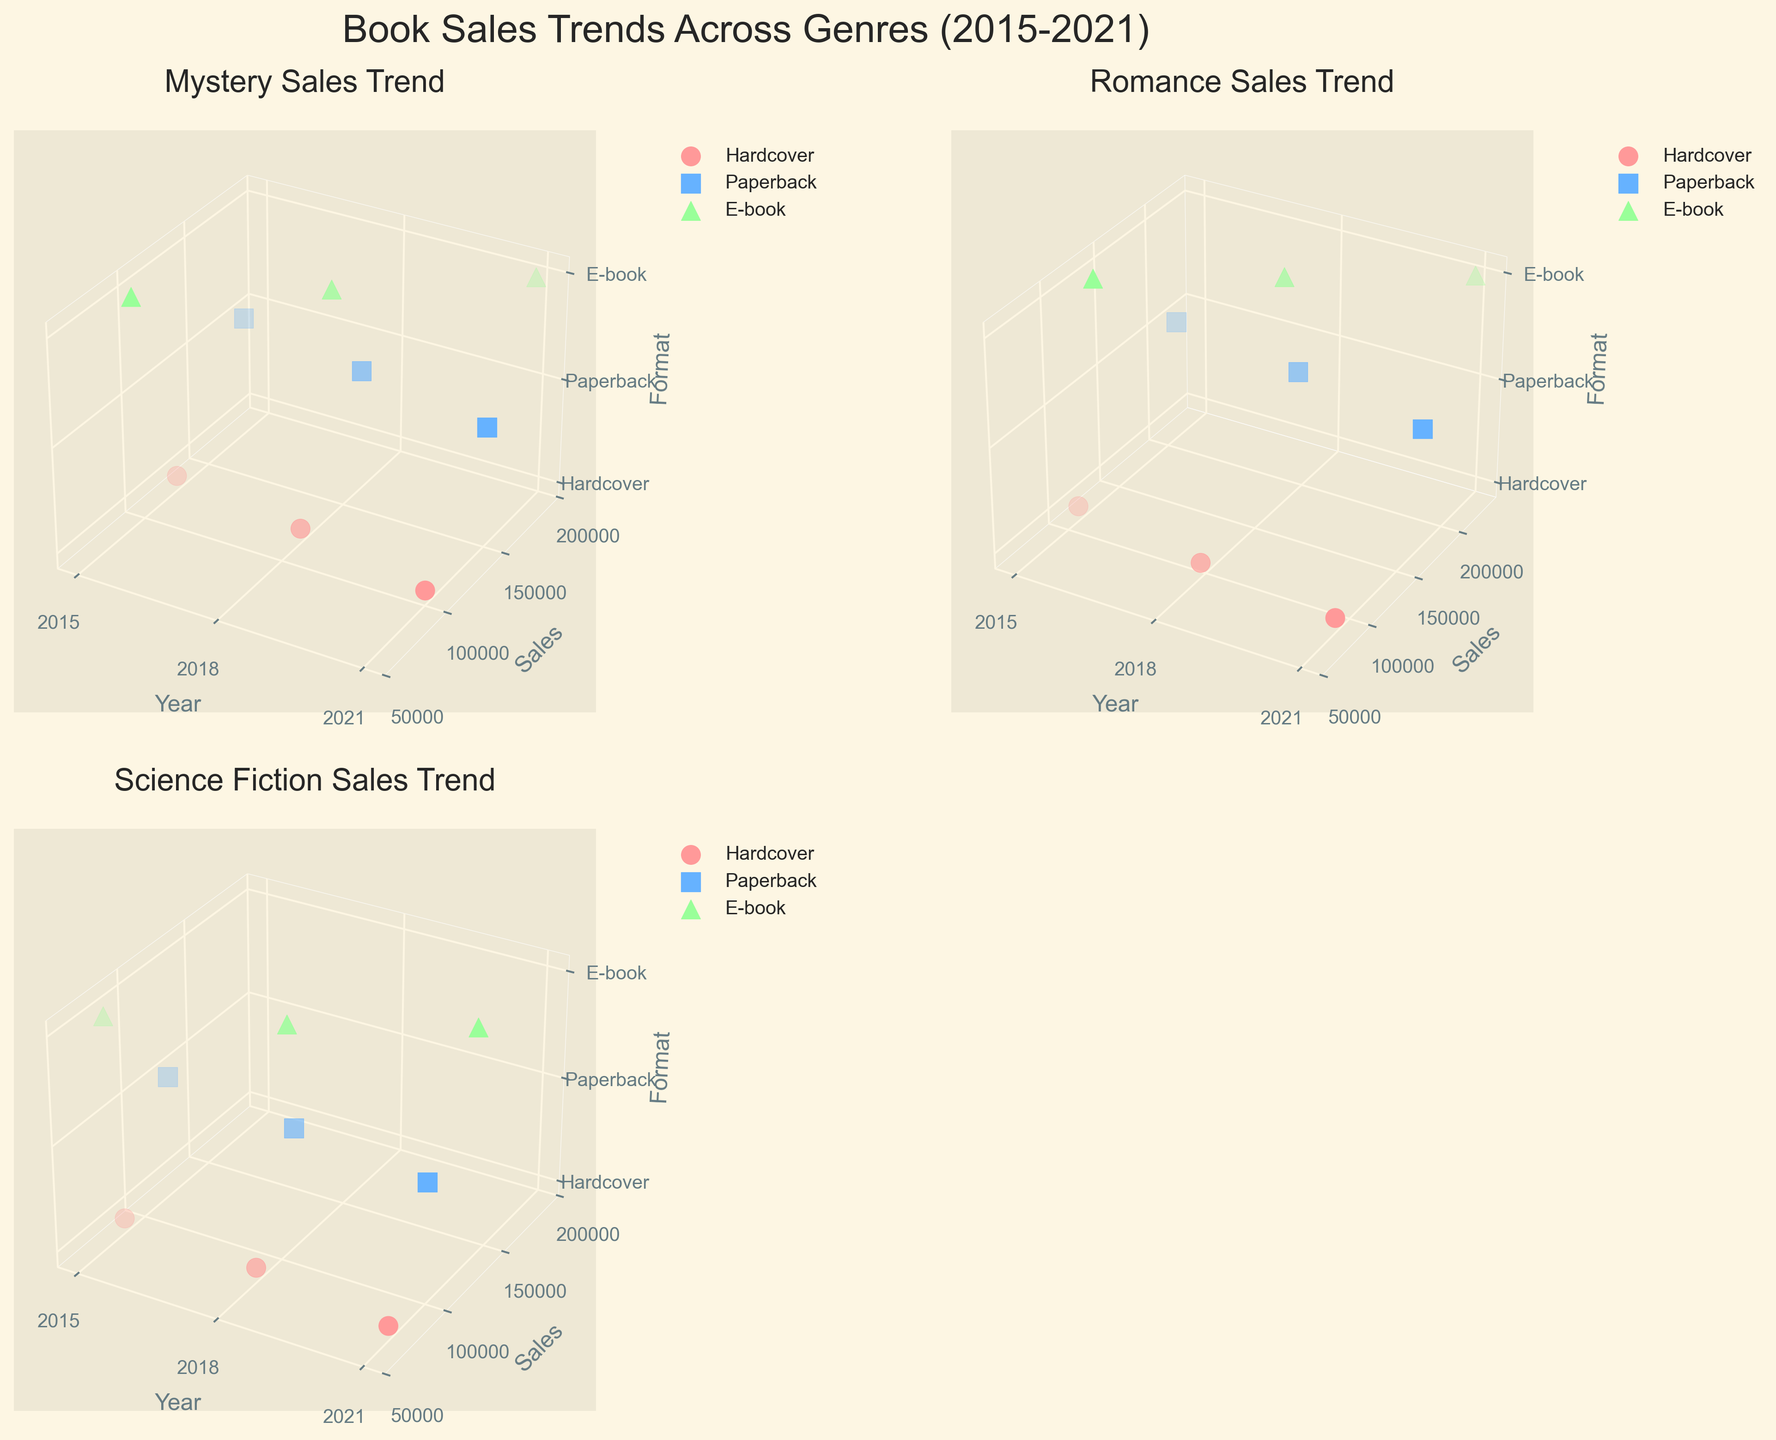How many genres are depicted in the figure? The figure shows four subplots corresponding to different genres. Each subplot title indicates a specific genre.
Answer: 3 What are the sales trends of Hardcovers in Mystery from 2015 to 2021? By examining the subplot for Mystery, identify the sales of Hardcovers in 2015, 2018, and 2021: 125,000 in 2015, 115,000 in 2018, and 100,000 in 2021. The trend is a decrease over time.
Answer: Decreasing Which genre has shown the highest E-book sales in 2021? Look at the E-book sales data points for 2021 in each genre subplot and compare them. Romance has the highest E-book sales with 230,000.
Answer: Romance What is the difference in Paperback sales between Romance and Science Fiction in 2018? In the subplots for 2018, note the Paperback sales: Romance has 195,000 and Science Fiction has 110,000. Subtract the latter from the former to get the difference: 195,000 - 110,000 = 85,000.
Answer: 85,000 Which format had the largest growth in Mystery sales from 2015 to 2021? Review the Mystery subplot. Compare sales of each format between 2015 and 2021: Hardcover (125,000 to 100,000), Paperback (180,000 to 150,000), and E-book (95,000 to 190,000). The E-book format had the largest growth.
Answer: E-book Do Paperback sales decline or increase for Romance from 2015 to 2021? Review the Romance subplot to compare Paperback sales in 2015 (210,000), 2018 (195,000), and 2021 (175,000). The trend shows a decline over time.
Answer: Decline Which genre had the most balanced sales among different formats in 2021? Examine each genre's subplot for 2021. Balanced sales among formats would have closer sales numbers across formats. Mystery has relatively balanced sales: 100,000 (Hardcover), 150,000 (Paperback), and 190,000 (E-book).
Answer: Mystery What was the overall sales trend for Science Fiction in E-book format from 2015 to 2021? Look at Science Fiction's E-book sales in 2015 (75,000), 2018 (105,000), and 2021 (140,000). The trend shows an increase.
Answer: Increasing 